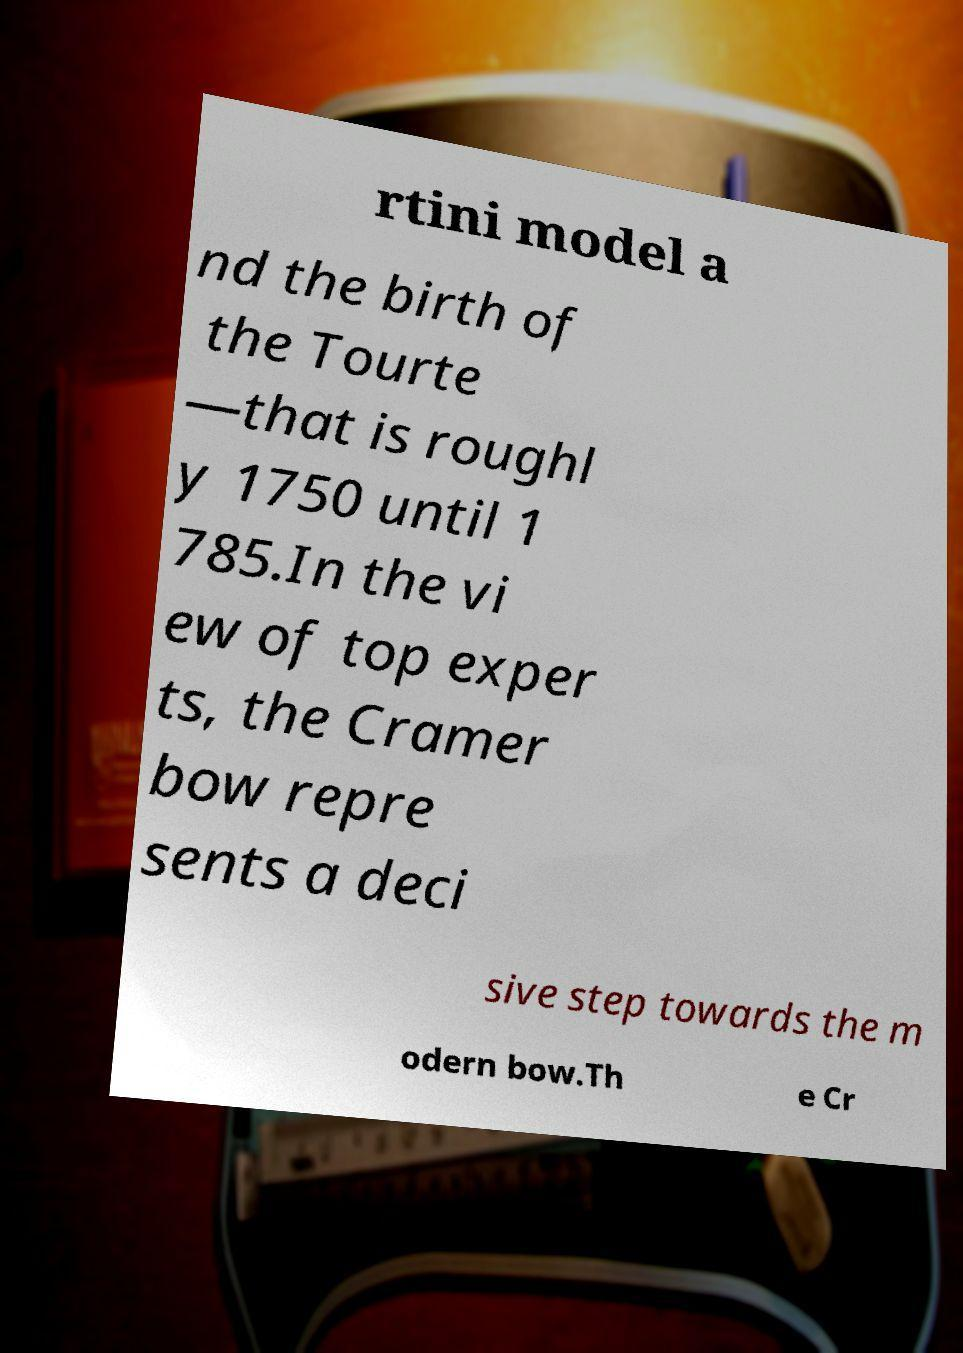For documentation purposes, I need the text within this image transcribed. Could you provide that? rtini model a nd the birth of the Tourte —that is roughl y 1750 until 1 785.In the vi ew of top exper ts, the Cramer bow repre sents a deci sive step towards the m odern bow.Th e Cr 